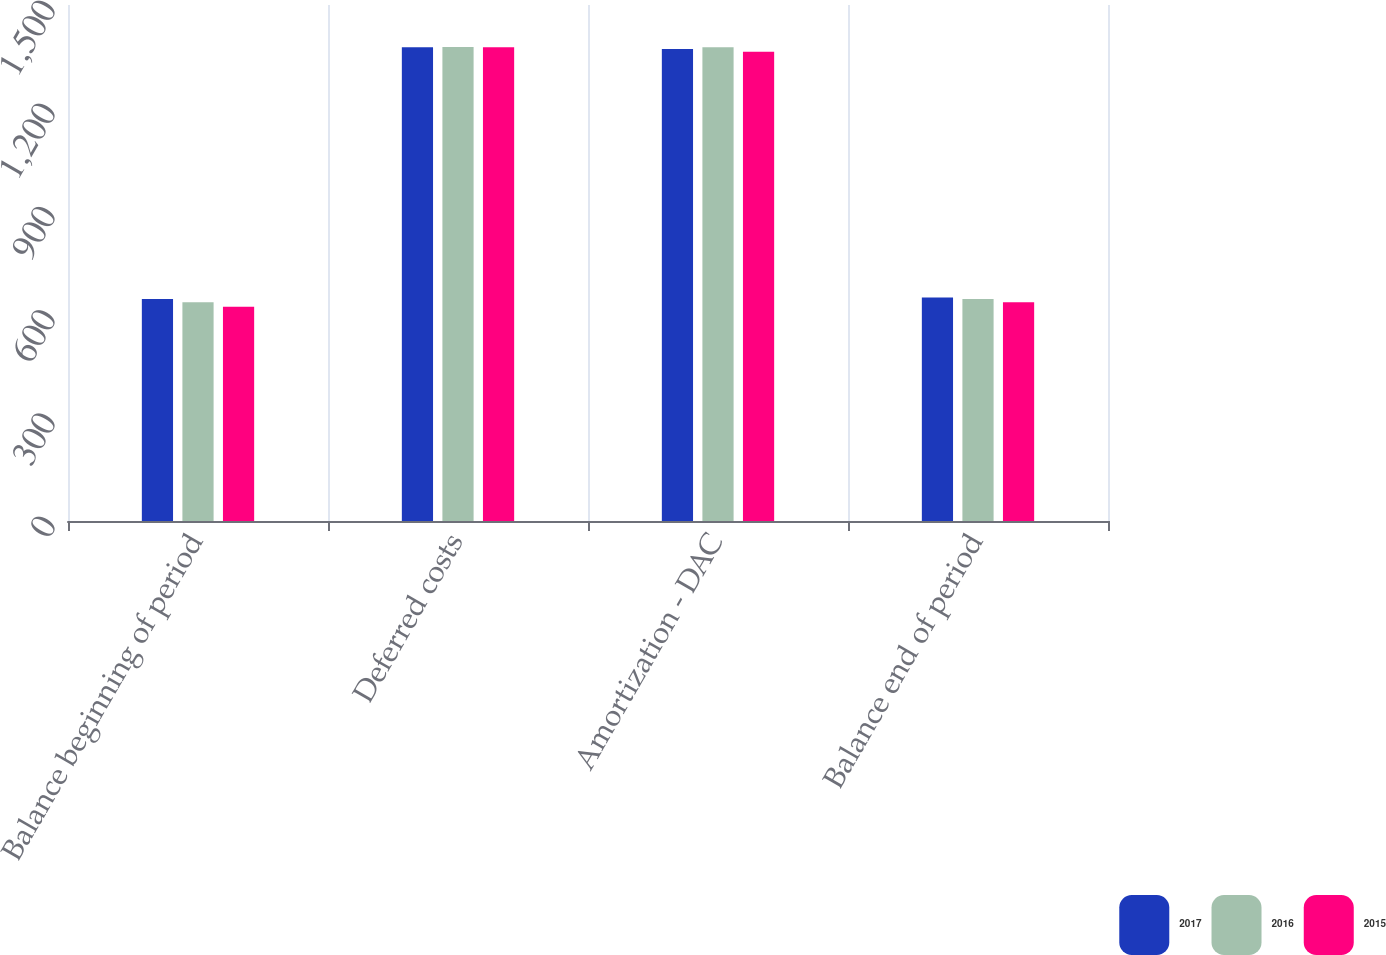Convert chart. <chart><loc_0><loc_0><loc_500><loc_500><stacked_bar_chart><ecel><fcel>Balance beginning of period<fcel>Deferred costs<fcel>Amortization - DAC<fcel>Balance end of period<nl><fcel>2017<fcel>645<fcel>1377<fcel>1372<fcel>650<nl><fcel>2016<fcel>636<fcel>1378<fcel>1377<fcel>645<nl><fcel>2015<fcel>623<fcel>1377<fcel>1364<fcel>636<nl></chart> 